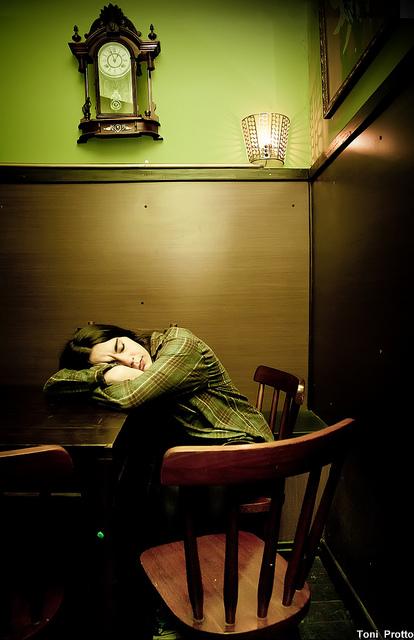Is the woman tired?
Concise answer only. Yes. Is there a clock in the photo?
Quick response, please. Yes. Do the women seem to be waiting on someone?
Keep it brief. Yes. 